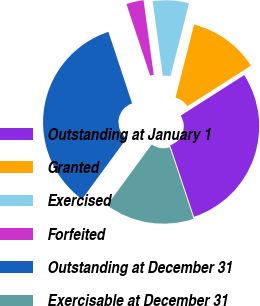<chart> <loc_0><loc_0><loc_500><loc_500><pie_chart><fcel>Outstanding at January 1<fcel>Granted<fcel>Exercised<fcel>Forfeited<fcel>Outstanding at December 31<fcel>Exercisable at December 31<nl><fcel>28.91%<fcel>12.0%<fcel>6.12%<fcel>2.93%<fcel>34.84%<fcel>15.19%<nl></chart> 